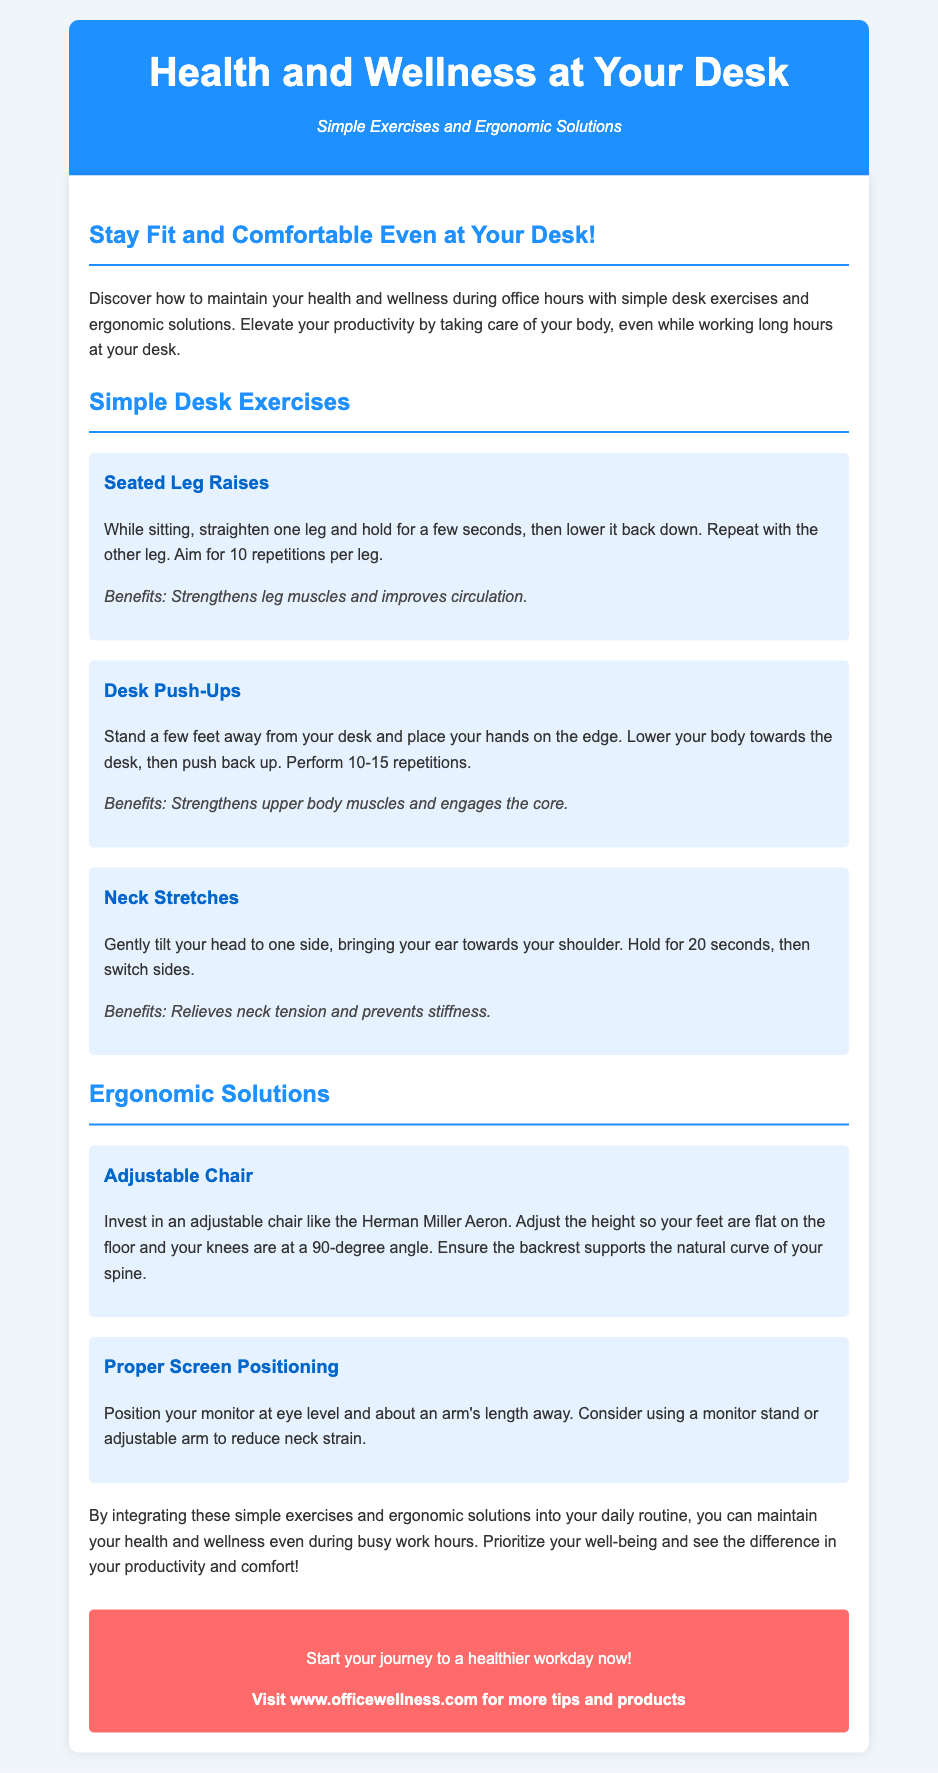What is the title of the document? The title is prominently displayed at the top of the document, presenting the main topic of health and wellness at work.
Answer: Health and Wellness at Your Desk What is the tagline? The tagline is a brief phrase that highlights the focus of the advertisement on exercises and solutions.
Answer: Simple Exercises and Ergonomic Solutions How many repetitions are recommended for Seated Leg Raises? The document specifies repetitions for the exercise, providing clear guidance for readers.
Answer: 10 What should the monitor position be? The document suggests an optimal monitor position to reduce strain, addressing ergonomic concerns.
Answer: Eye level What is one benefit of Neck Stretches? The document lists benefits for each exercise, summarizing the positive effects of the stretches.
Answer: Relieves neck tension What type of chair is suggested in the ergonomic solutions? The advertisement recommends a specific type of chair, indicating its importance for comfort during work.
Answer: Adjustable chair How long should you hold the Neck Stretch? The document provides specific guidance on the duration for performing neck stretches, which enhances the exercise's effectiveness.
Answer: 20 seconds What is the call to action? The call to action encourages readers to take a specific step toward improving their work-life.
Answer: Start your journey to a healthier workday now! 